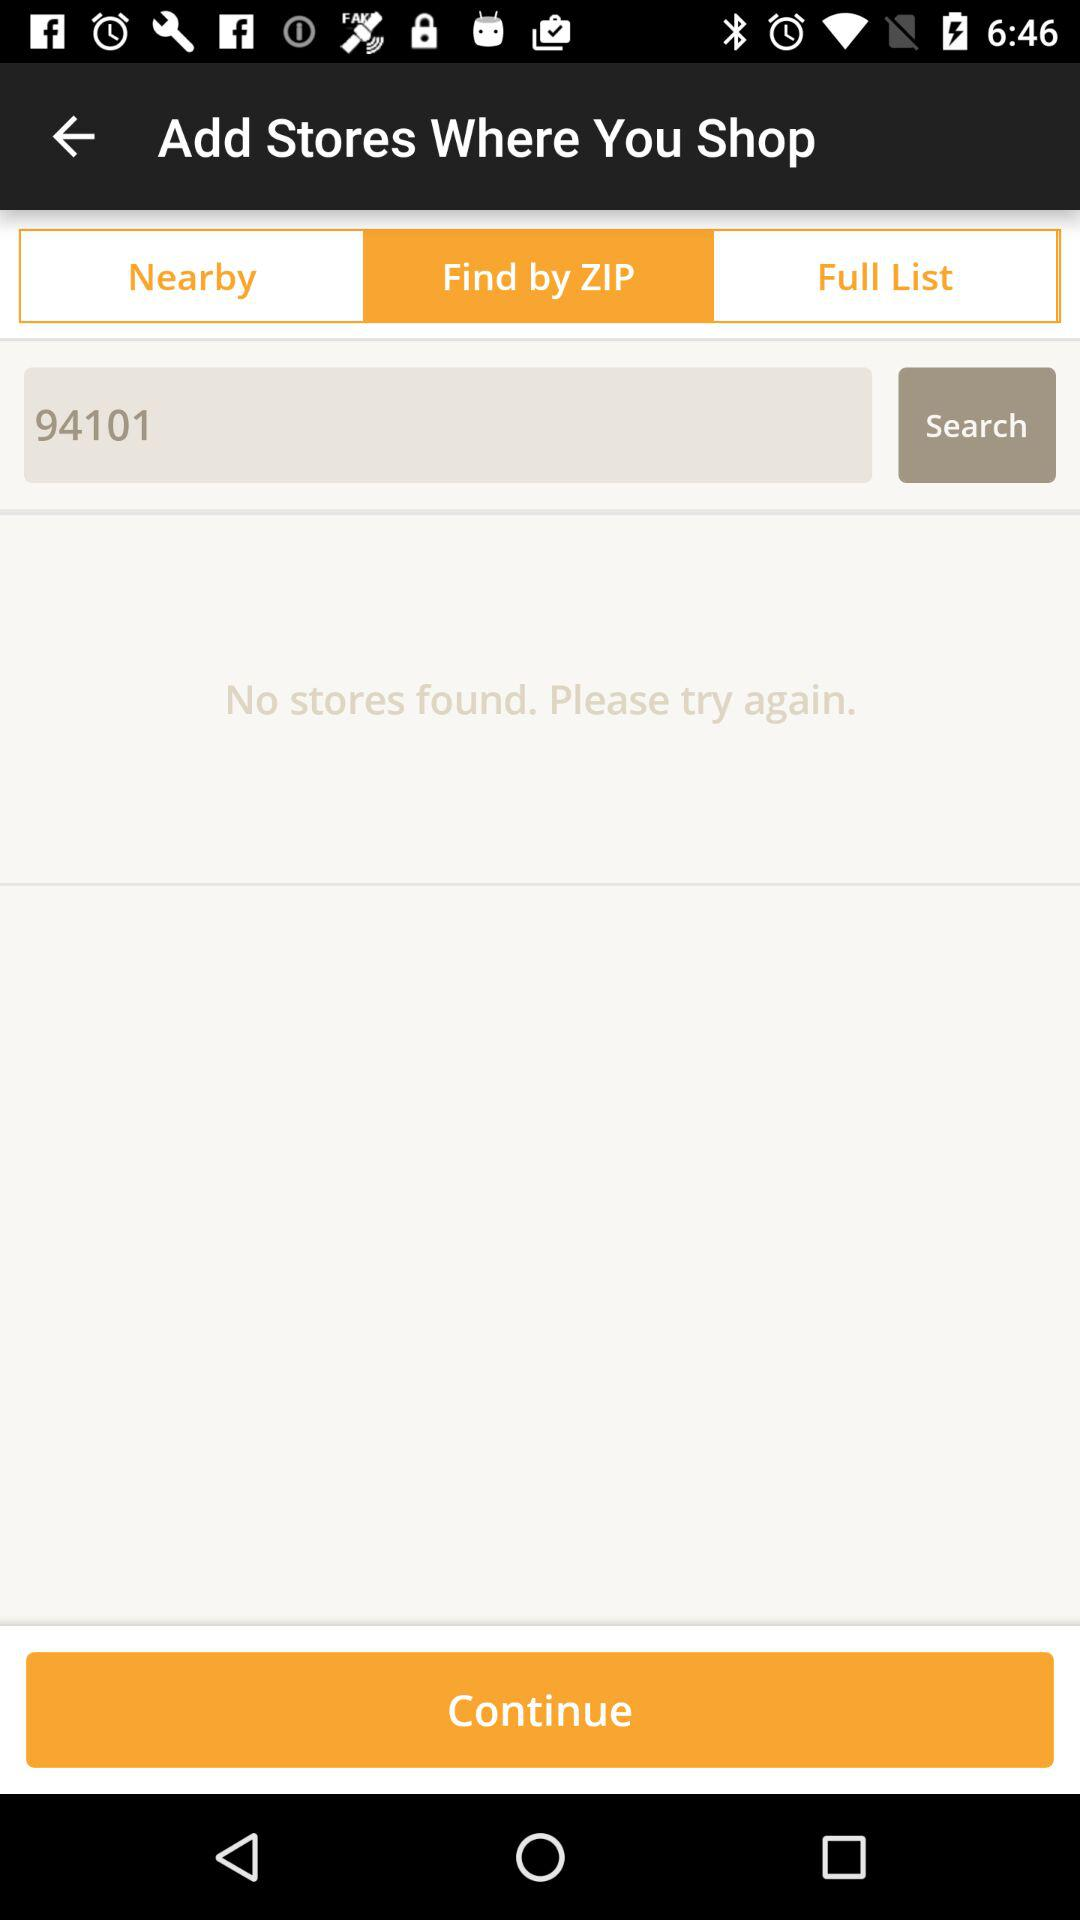What is the input entered in the search bar? The input entered is 94101. 